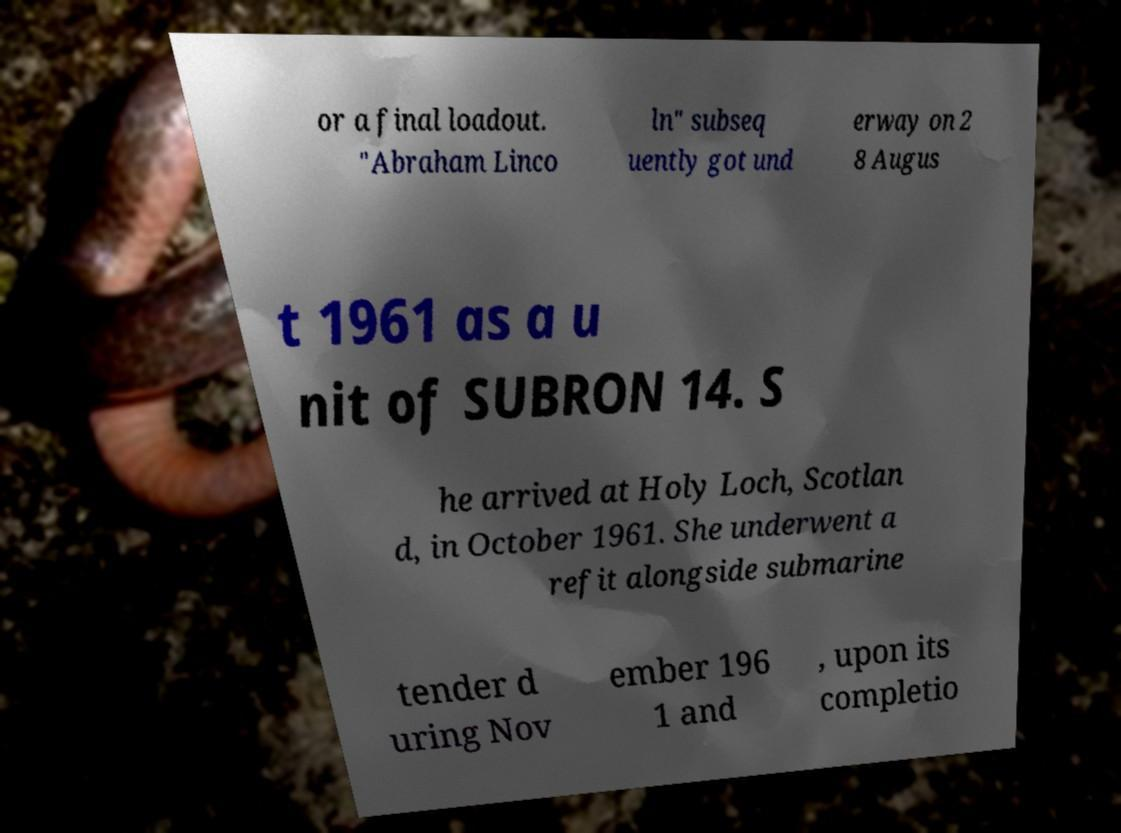Please read and relay the text visible in this image. What does it say? or a final loadout. "Abraham Linco ln" subseq uently got und erway on 2 8 Augus t 1961 as a u nit of SUBRON 14. S he arrived at Holy Loch, Scotlan d, in October 1961. She underwent a refit alongside submarine tender d uring Nov ember 196 1 and , upon its completio 